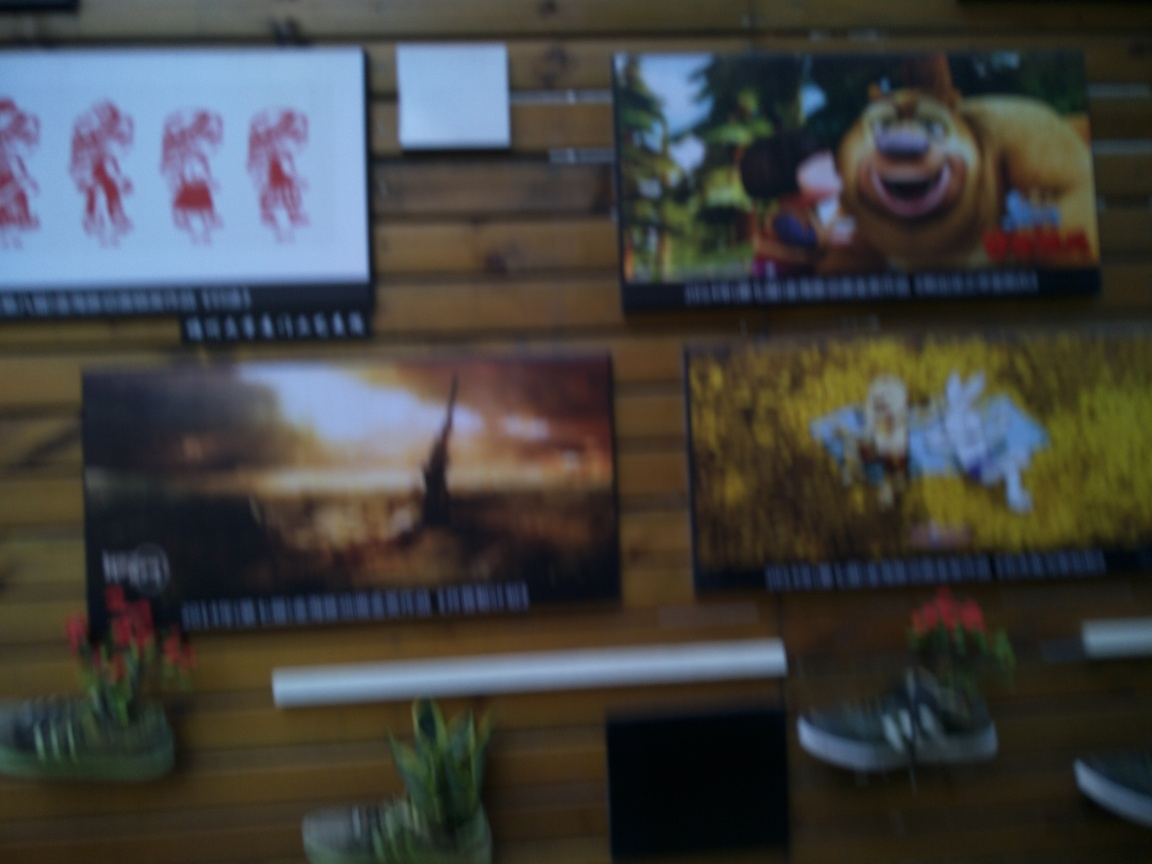Do the colors appear natural? From the image provided, the colors do not seem natural as the image is quite blurry and the true color representation cannot be accurately determined. In a well-focused image, colors should be crisp and readily discernible, which is not the case here. Thus, based on the provided image, the naturalness of the colors cannot be conclusively assessed. 